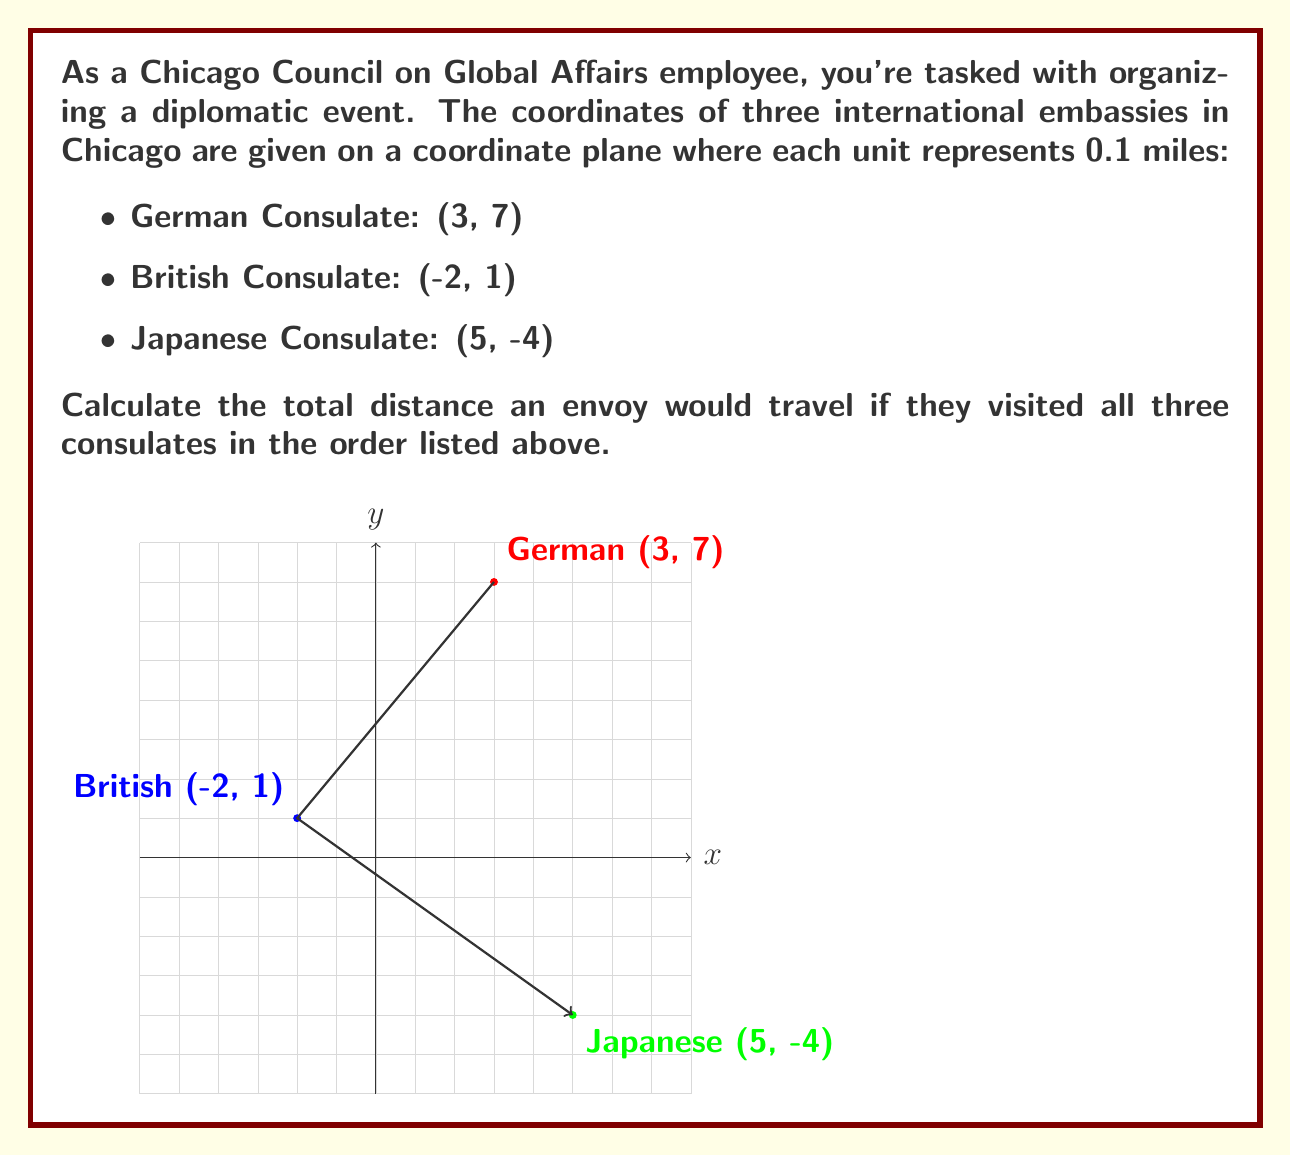Teach me how to tackle this problem. Let's approach this step-by-step:

1) To calculate the distance between two points, we use the distance formula:
   $$d = \sqrt{(x_2-x_1)^2 + (y_2-y_1)^2}$$

2) First, let's calculate the distance from the German to the British Consulate:
   $$d_{GB} = \sqrt{(-2-3)^2 + (1-7)^2} = \sqrt{(-5)^2 + (-6)^2} = \sqrt{25 + 36} = \sqrt{61}$$

3) Next, calculate the distance from the British to the Japanese Consulate:
   $$d_{BJ} = \sqrt{(5-(-2))^2 + (-4-1)^2} = \sqrt{7^2 + (-5)^2} = \sqrt{49 + 25} = \sqrt{74}$$

4) The total distance is the sum of these two distances:
   $$d_{total} = \sqrt{61} + \sqrt{74}$$

5) Simplify:
   $$d_{total} \approx 7.81 + 8.60 = 16.41$$

6) Remember that each unit represents 0.1 miles, so multiply by 0.1:
   $$16.41 * 0.1 = 1.641$$

Therefore, the total distance traveled is approximately 1.641 miles.
Answer: 1.641 miles 